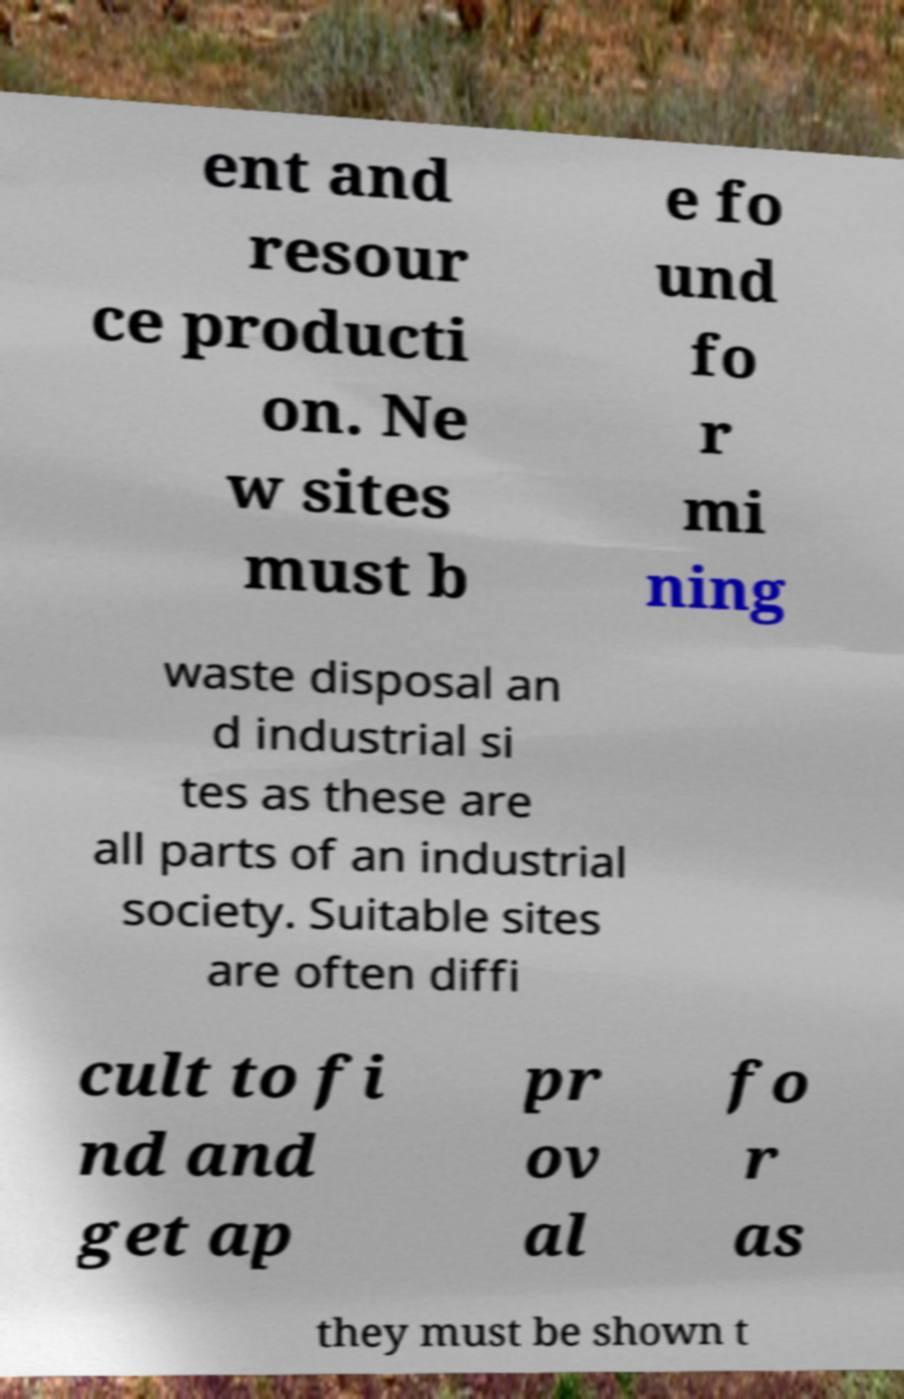Please read and relay the text visible in this image. What does it say? ent and resour ce producti on. Ne w sites must b e fo und fo r mi ning waste disposal an d industrial si tes as these are all parts of an industrial society. Suitable sites are often diffi cult to fi nd and get ap pr ov al fo r as they must be shown t 